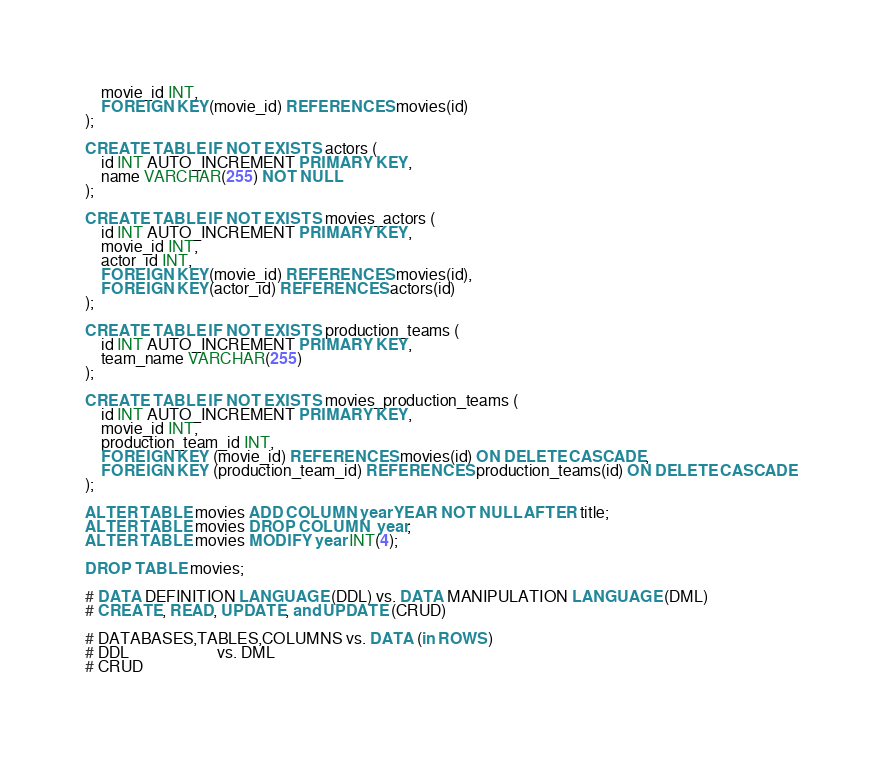Convert code to text. <code><loc_0><loc_0><loc_500><loc_500><_SQL_>    movie_id INT,
    FOREIGN KEY(movie_id) REFERENCES movies(id)
);

CREATE TABLE IF NOT EXISTS actors (
    id INT AUTO_INCREMENT PRIMARY KEY,
    name VARCHAR(255) NOT NULL
);

CREATE TABLE IF NOT EXISTS movies_actors (
    id INT AUTO_INCREMENT PRIMARY KEY,
    movie_id INT,
    actor_id INT,
    FOREIGN KEY(movie_id) REFERENCES movies(id),
    FOREIGN KEY(actor_id) REFERENCES actors(id)
);

CREATE TABLE IF NOT EXISTS production_teams (
    id INT AUTO_INCREMENT PRIMARY KEY,
    team_name VARCHAR(255)
);

CREATE TABLE IF NOT EXISTS movies_production_teams (
    id INT AUTO_INCREMENT PRIMARY KEY,
    movie_id INT,
    production_team_id INT,
    FOREIGN KEY (movie_id) REFERENCES movies(id) ON DELETE CASCADE,
    FOREIGN KEY (production_team_id) REFERENCES production_teams(id) ON DELETE CASCADE
);

ALTER TABLE movies ADD COLUMN year YEAR NOT NULL AFTER title;
ALTER TABLE movies DROP COLUMN  year;
ALTER TABLE movies MODIFY year INT(4);

DROP TABLE movies;

# DATA DEFINITION LANGUAGE (DDL) vs. DATA MANIPULATION LANGUAGE (DML)
# CREATE, READ, UPDATE, and UPDATE (CRUD)

# DATABASES,TABLES,COLUMNS vs. DATA (in ROWS)
# DDL                      vs. DML
# CRUD

</code> 